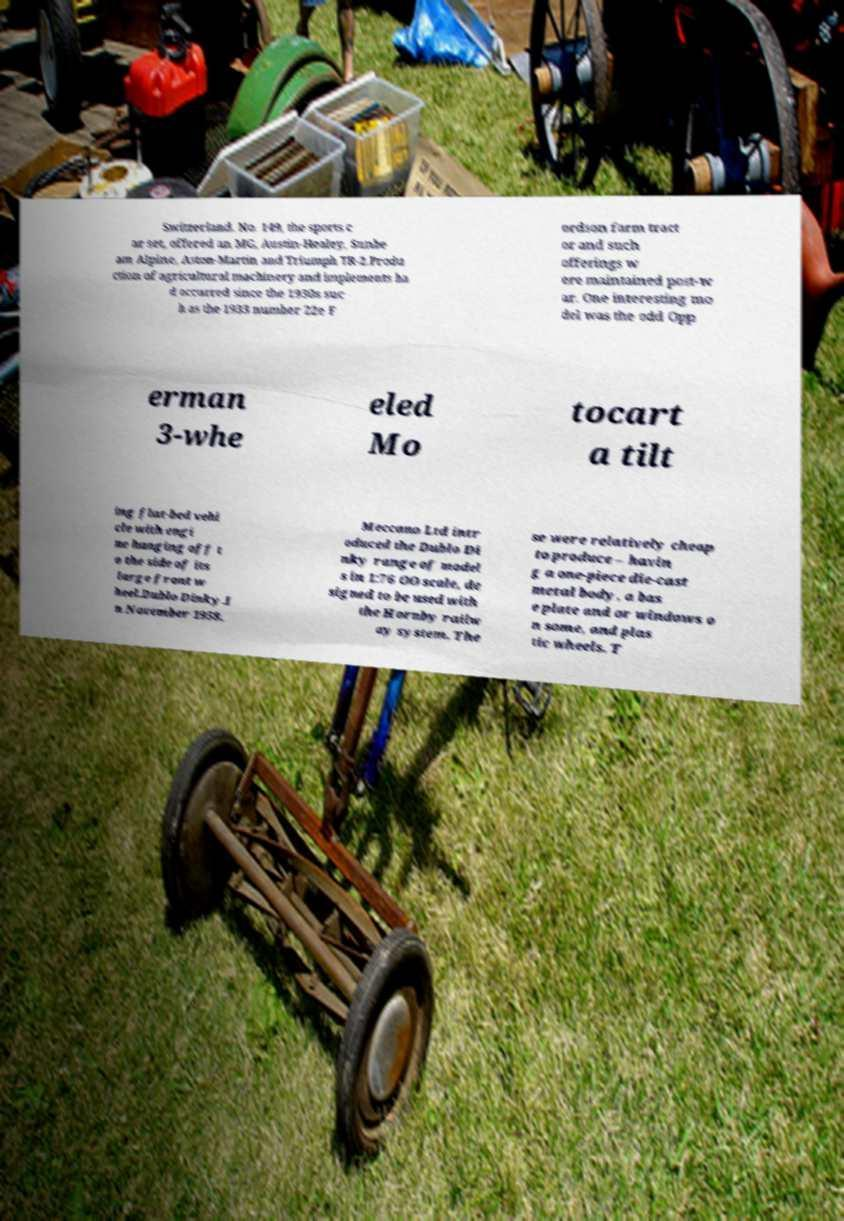For documentation purposes, I need the text within this image transcribed. Could you provide that? Switzerland. No. 149, the sports c ar set, offered an MG, Austin-Healey, Sunbe am Alpine, Aston-Martin and Triumph TR-2.Produ ction of agricultural machinery and implements ha d occurred since the 1930s suc h as the 1933 number 22e F ordson farm tract or and such offerings w ere maintained post-w ar. One interesting mo del was the odd Opp erman 3-whe eled Mo tocart a tilt ing flat-bed vehi cle with engi ne hanging off t o the side of its large front w heel.Dublo Dinky.I n November 1958, Meccano Ltd intr oduced the Dublo Di nky range of model s in 1:76 OO scale, de signed to be used with the Hornby railw ay system. The se were relatively cheap to produce – havin g a one-piece die-cast metal body, a bas e plate and or windows o n some, and plas tic wheels. T 